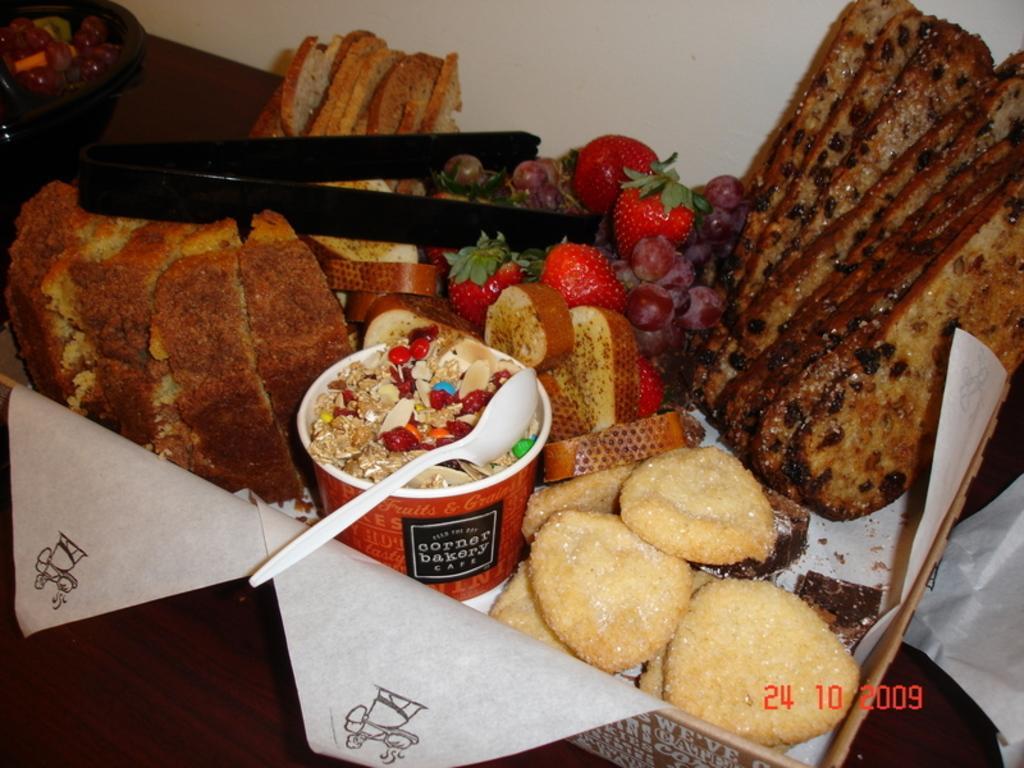In one or two sentences, can you explain what this image depicts? In this image there is a box on a wooden surface. In the box there are food. There are biscuits, bread, strawberry, grapes and toast in the box. There is a glass and a spoon in the box. On the food there are tongs. At the top there is a wall. 